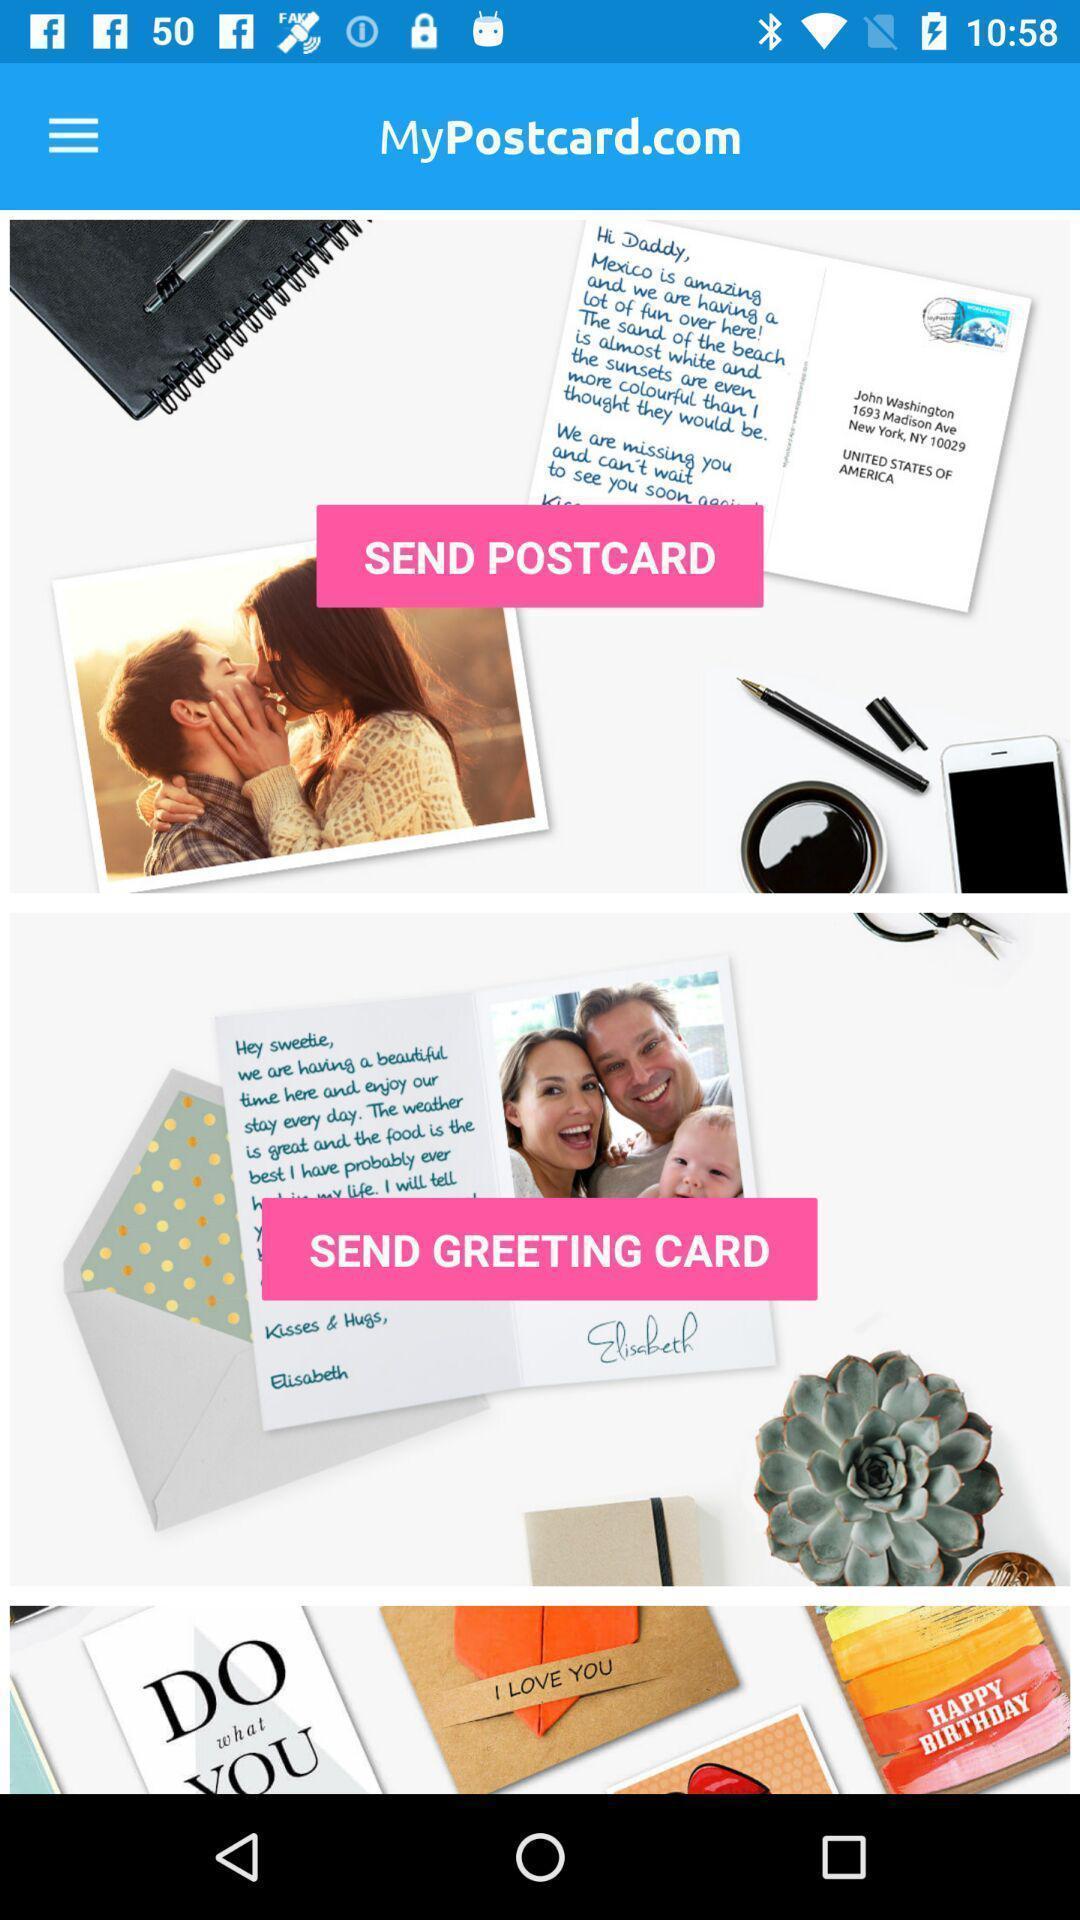Tell me what you see in this picture. Starting page. 